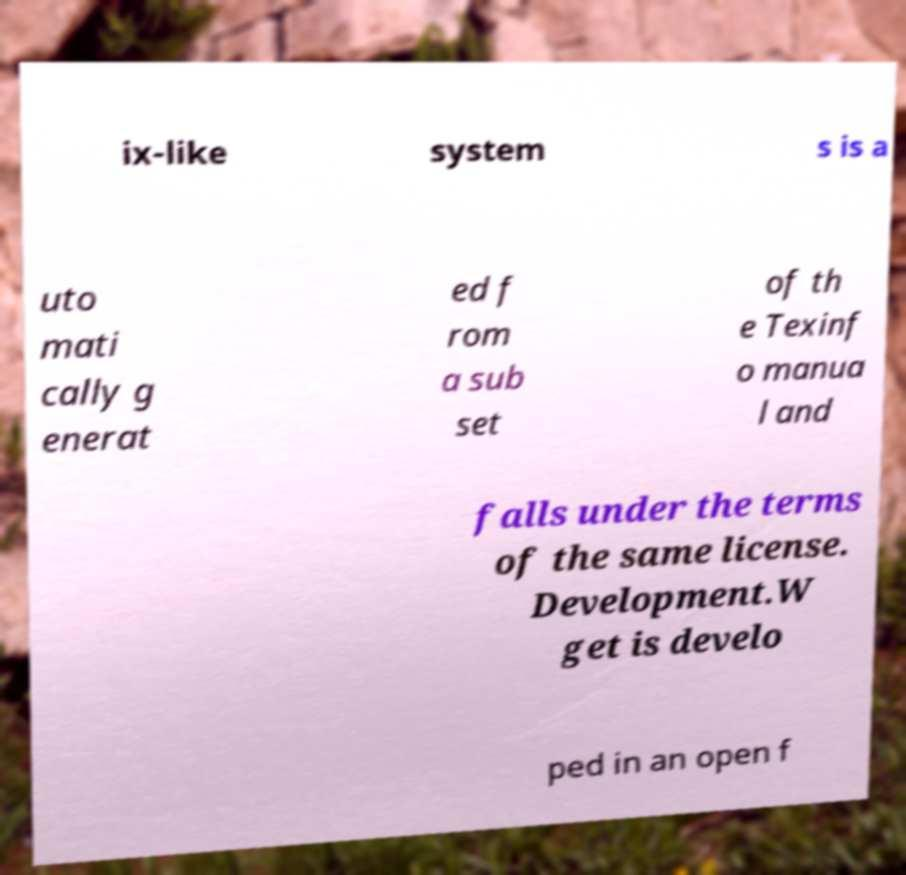Please identify and transcribe the text found in this image. ix-like system s is a uto mati cally g enerat ed f rom a sub set of th e Texinf o manua l and falls under the terms of the same license. Development.W get is develo ped in an open f 